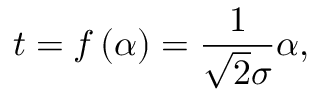Convert formula to latex. <formula><loc_0><loc_0><loc_500><loc_500>t = f \left ( \alpha \right ) = \frac { 1 } { \sqrt { 2 } \sigma } \alpha ,</formula> 